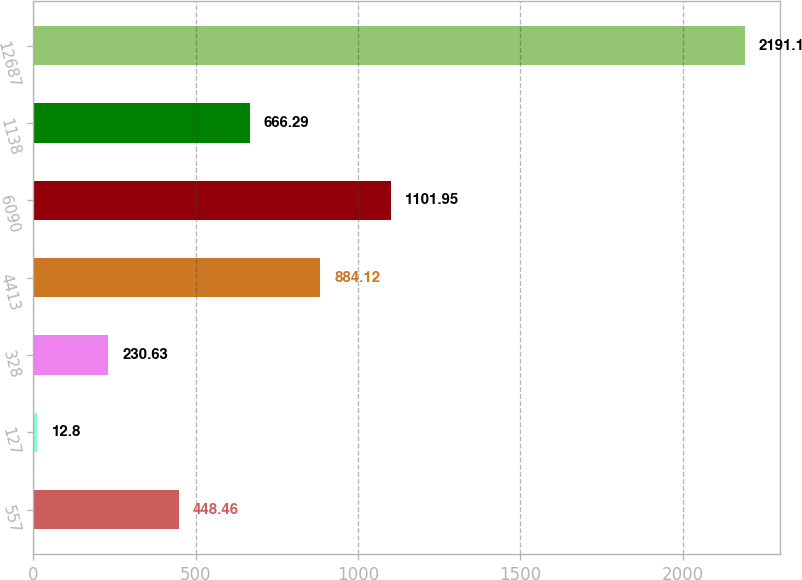<chart> <loc_0><loc_0><loc_500><loc_500><bar_chart><fcel>557<fcel>127<fcel>328<fcel>4413<fcel>6090<fcel>1138<fcel>12687<nl><fcel>448.46<fcel>12.8<fcel>230.63<fcel>884.12<fcel>1101.95<fcel>666.29<fcel>2191.1<nl></chart> 